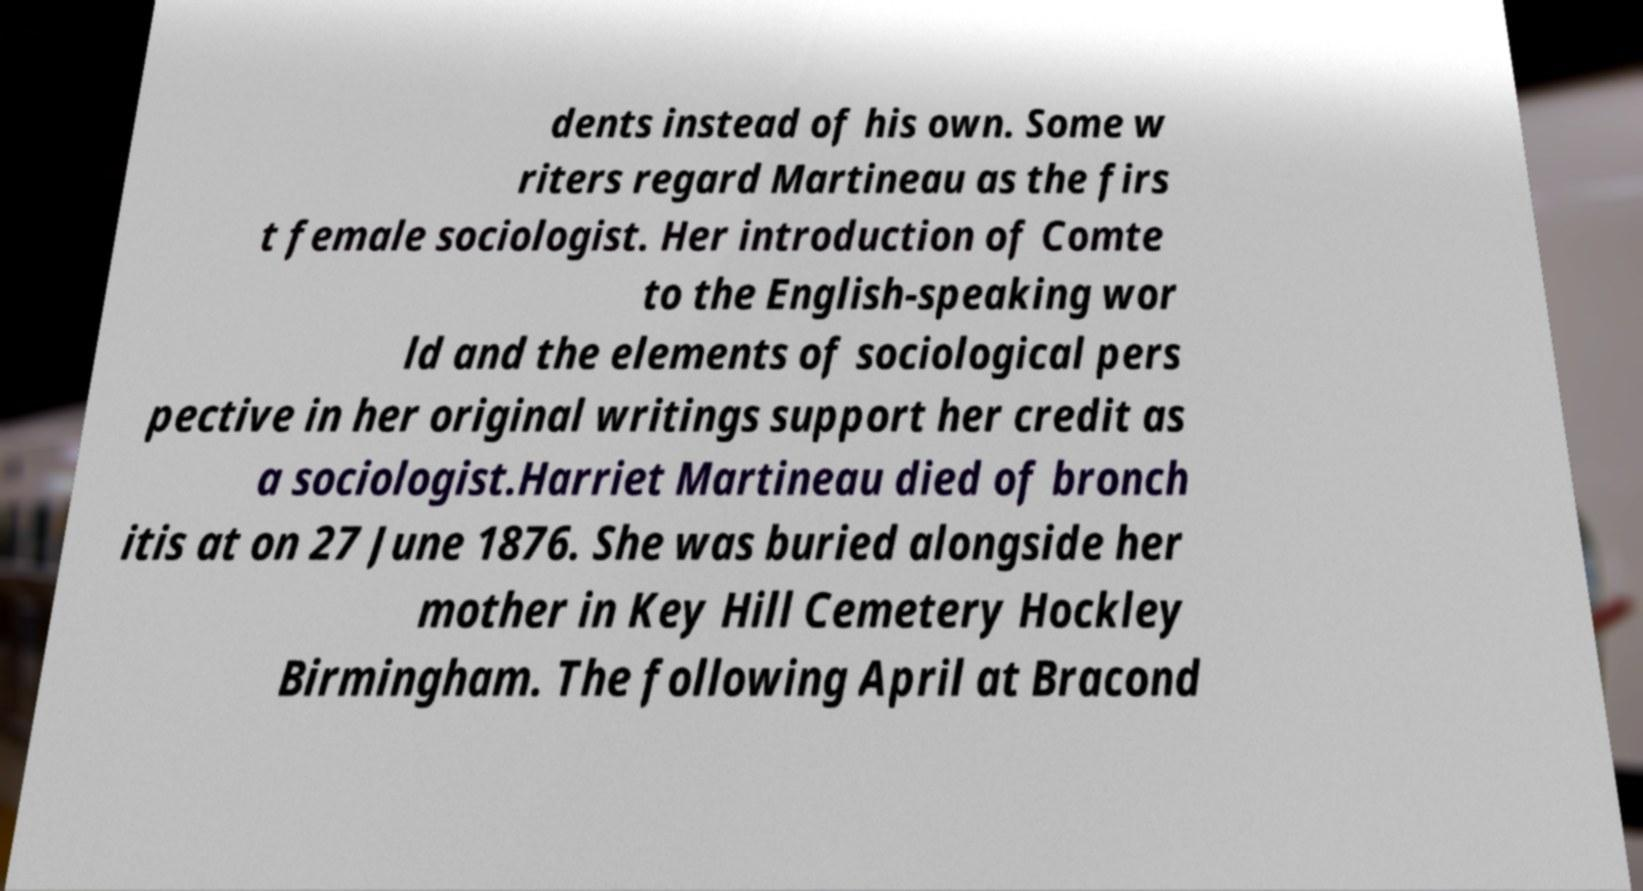Can you read and provide the text displayed in the image?This photo seems to have some interesting text. Can you extract and type it out for me? dents instead of his own. Some w riters regard Martineau as the firs t female sociologist. Her introduction of Comte to the English-speaking wor ld and the elements of sociological pers pective in her original writings support her credit as a sociologist.Harriet Martineau died of bronch itis at on 27 June 1876. She was buried alongside her mother in Key Hill Cemetery Hockley Birmingham. The following April at Bracond 